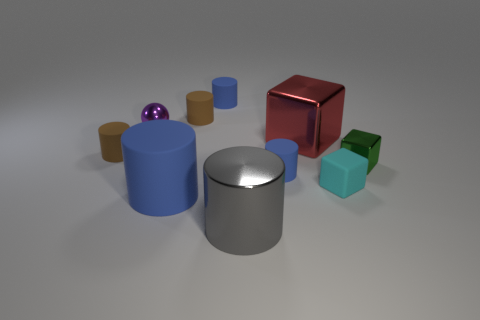Are there any other things that have the same material as the purple thing?
Offer a terse response. Yes. What number of gray metallic cylinders are on the right side of the blue matte cylinder on the right side of the blue thing behind the small green metallic cube?
Offer a very short reply. 0. There is a object that is on the left side of the purple metal thing; does it have the same shape as the small cyan rubber object?
Your answer should be compact. No. What number of things are either purple balls or blue matte cylinders in front of the tiny cyan thing?
Your answer should be very brief. 2. Are there more tiny green metal cubes that are on the right side of the large blue object than purple balls?
Give a very brief answer. No. Are there the same number of big rubber cylinders to the left of the small purple thing and blue matte cylinders that are in front of the large red metal thing?
Offer a very short reply. No. There is a tiny brown matte cylinder that is behind the tiny purple metal thing; are there any small things that are behind it?
Provide a succinct answer. Yes. What is the shape of the large red metal thing?
Give a very brief answer. Cube. How big is the metal object in front of the small metal object that is on the right side of the tiny matte cube?
Offer a very short reply. Large. What is the size of the metallic cube that is right of the tiny cyan rubber object?
Give a very brief answer. Small. 